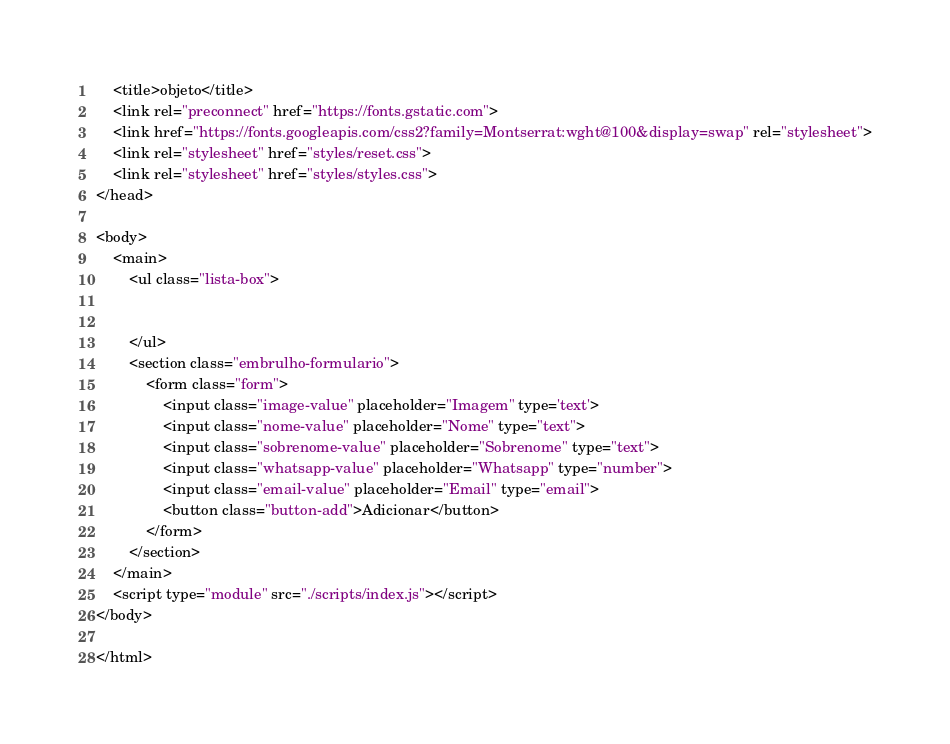<code> <loc_0><loc_0><loc_500><loc_500><_HTML_>    <title>objeto</title>
    <link rel="preconnect" href="https://fonts.gstatic.com">
    <link href="https://fonts.googleapis.com/css2?family=Montserrat:wght@100&display=swap" rel="stylesheet">
    <link rel="stylesheet" href="styles/reset.css">
    <link rel="stylesheet" href="styles/styles.css">
</head>

<body>
    <main>
        <ul class="lista-box">


        </ul>
        <section class="embrulho-formulario">
            <form class="form">
                <input class="image-value" placeholder="Imagem" type='text'>
                <input class="nome-value" placeholder="Nome" type="text">
                <input class="sobrenome-value" placeholder="Sobrenome" type="text">
                <input class="whatsapp-value" placeholder="Whatsapp" type="number">
                <input class="email-value" placeholder="Email" type="email">
                <button class="button-add">Adicionar</button>
            </form>
        </section>
    </main>
    <script type="module" src="./scripts/index.js"></script>
</body>

</html></code> 